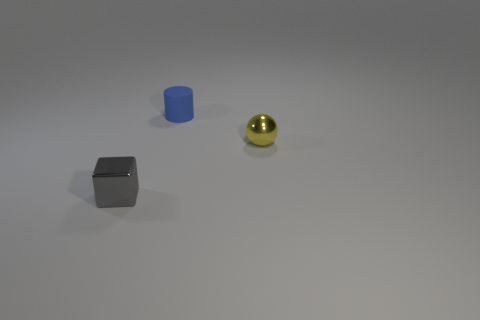Subtract all red cubes. Subtract all cyan cylinders. How many cubes are left? 1 Add 3 tiny green matte things. How many objects exist? 6 Subtract all blocks. How many objects are left? 2 Add 2 small blue matte cylinders. How many small blue matte cylinders are left? 3 Add 1 large blue metal cylinders. How many large blue metal cylinders exist? 1 Subtract 0 cyan cylinders. How many objects are left? 3 Subtract all blue rubber cylinders. Subtract all purple metallic spheres. How many objects are left? 2 